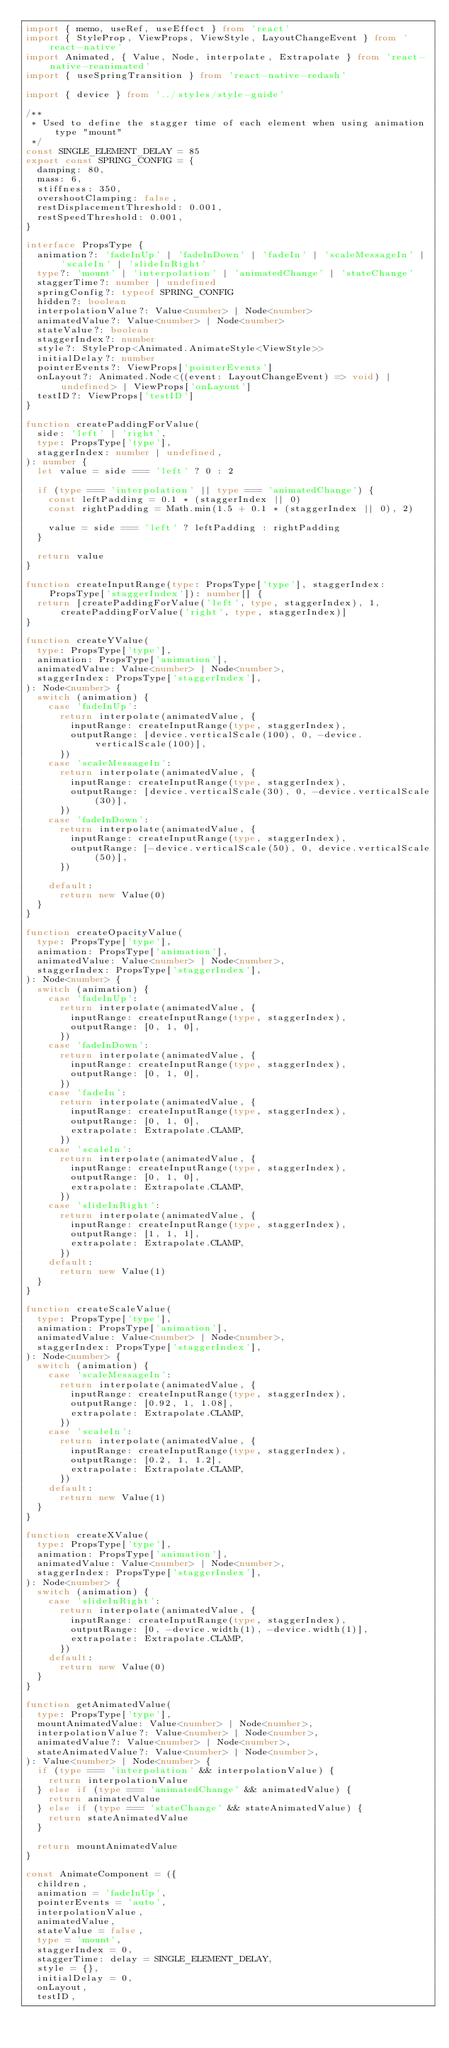Convert code to text. <code><loc_0><loc_0><loc_500><loc_500><_TypeScript_>import { memo, useRef, useEffect } from 'react'
import { StyleProp, ViewProps, ViewStyle, LayoutChangeEvent } from 'react-native'
import Animated, { Value, Node, interpolate, Extrapolate } from 'react-native-reanimated'
import { useSpringTransition } from 'react-native-redash'

import { device } from '../styles/style-guide'

/**
 * Used to define the stagger time of each element when using animation type "mount"
 */
const SINGLE_ELEMENT_DELAY = 85
export const SPRING_CONFIG = {
  damping: 80,
  mass: 6,
  stiffness: 350,
  overshootClamping: false,
  restDisplacementThreshold: 0.001,
  restSpeedThreshold: 0.001,
}

interface PropsType {
  animation?: 'fadeInUp' | 'fadeInDown' | 'fadeIn' | 'scaleMessageIn' | 'scaleIn' | 'slideInRight'
  type?: 'mount' | 'interpolation' | 'animatedChange' | 'stateChange'
  staggerTime?: number | undefined
  springConfig?: typeof SPRING_CONFIG
  hidden?: boolean
  interpolationValue?: Value<number> | Node<number>
  animatedValue?: Value<number> | Node<number>
  stateValue?: boolean
  staggerIndex?: number
  style?: StyleProp<Animated.AnimateStyle<ViewStyle>>
  initialDelay?: number
  pointerEvents?: ViewProps['pointerEvents']
  onLayout?: Animated.Node<((event: LayoutChangeEvent) => void) | undefined> | ViewProps['onLayout']
  testID?: ViewProps['testID']
}

function createPaddingForValue(
  side: 'left' | 'right',
  type: PropsType['type'],
  staggerIndex: number | undefined,
): number {
  let value = side === 'left' ? 0 : 2

  if (type === 'interpolation' || type === 'animatedChange') {
    const leftPadding = 0.1 * (staggerIndex || 0)
    const rightPadding = Math.min(1.5 + 0.1 * (staggerIndex || 0), 2)

    value = side === 'left' ? leftPadding : rightPadding
  }

  return value
}

function createInputRange(type: PropsType['type'], staggerIndex: PropsType['staggerIndex']): number[] {
  return [createPaddingForValue('left', type, staggerIndex), 1, createPaddingForValue('right', type, staggerIndex)]
}

function createYValue(
  type: PropsType['type'],
  animation: PropsType['animation'],
  animatedValue: Value<number> | Node<number>,
  staggerIndex: PropsType['staggerIndex'],
): Node<number> {
  switch (animation) {
    case 'fadeInUp':
      return interpolate(animatedValue, {
        inputRange: createInputRange(type, staggerIndex),
        outputRange: [device.verticalScale(100), 0, -device.verticalScale(100)],
      })
    case 'scaleMessageIn':
      return interpolate(animatedValue, {
        inputRange: createInputRange(type, staggerIndex),
        outputRange: [device.verticalScale(30), 0, -device.verticalScale(30)],
      })
    case 'fadeInDown':
      return interpolate(animatedValue, {
        inputRange: createInputRange(type, staggerIndex),
        outputRange: [-device.verticalScale(50), 0, device.verticalScale(50)],
      })

    default:
      return new Value(0)
  }
}

function createOpacityValue(
  type: PropsType['type'],
  animation: PropsType['animation'],
  animatedValue: Value<number> | Node<number>,
  staggerIndex: PropsType['staggerIndex'],
): Node<number> {
  switch (animation) {
    case 'fadeInUp':
      return interpolate(animatedValue, {
        inputRange: createInputRange(type, staggerIndex),
        outputRange: [0, 1, 0],
      })
    case 'fadeInDown':
      return interpolate(animatedValue, {
        inputRange: createInputRange(type, staggerIndex),
        outputRange: [0, 1, 0],
      })
    case 'fadeIn':
      return interpolate(animatedValue, {
        inputRange: createInputRange(type, staggerIndex),
        outputRange: [0, 1, 0],
        extrapolate: Extrapolate.CLAMP,
      })
    case 'scaleIn':
      return interpolate(animatedValue, {
        inputRange: createInputRange(type, staggerIndex),
        outputRange: [0, 1, 0],
        extrapolate: Extrapolate.CLAMP,
      })
    case 'slideInRight':
      return interpolate(animatedValue, {
        inputRange: createInputRange(type, staggerIndex),
        outputRange: [1, 1, 1],
        extrapolate: Extrapolate.CLAMP,
      })
    default:
      return new Value(1)
  }
}

function createScaleValue(
  type: PropsType['type'],
  animation: PropsType['animation'],
  animatedValue: Value<number> | Node<number>,
  staggerIndex: PropsType['staggerIndex'],
): Node<number> {
  switch (animation) {
    case 'scaleMessageIn':
      return interpolate(animatedValue, {
        inputRange: createInputRange(type, staggerIndex),
        outputRange: [0.92, 1, 1.08],
        extrapolate: Extrapolate.CLAMP,
      })
    case 'scaleIn':
      return interpolate(animatedValue, {
        inputRange: createInputRange(type, staggerIndex),
        outputRange: [0.2, 1, 1.2],
        extrapolate: Extrapolate.CLAMP,
      })
    default:
      return new Value(1)
  }
}

function createXValue(
  type: PropsType['type'],
  animation: PropsType['animation'],
  animatedValue: Value<number> | Node<number>,
  staggerIndex: PropsType['staggerIndex'],
): Node<number> {
  switch (animation) {
    case 'slideInRight':
      return interpolate(animatedValue, {
        inputRange: createInputRange(type, staggerIndex),
        outputRange: [0, -device.width(1), -device.width(1)],
        extrapolate: Extrapolate.CLAMP,
      })
    default:
      return new Value(0)
  }
}

function getAnimatedValue(
  type: PropsType['type'],
  mountAnimatedValue: Value<number> | Node<number>,
  interpolationValue?: Value<number> | Node<number>,
  animatedValue?: Value<number> | Node<number>,
  stateAnimatedValue?: Value<number> | Node<number>,
): Value<number> | Node<number> {
  if (type === 'interpolation' && interpolationValue) {
    return interpolationValue
  } else if (type === 'animatedChange' && animatedValue) {
    return animatedValue
  } else if (type === 'stateChange' && stateAnimatedValue) {
    return stateAnimatedValue
  }

  return mountAnimatedValue
}

const AnimateComponent = ({
  children,
  animation = 'fadeInUp',
  pointerEvents = 'auto',
  interpolationValue,
  animatedValue,
  stateValue = false,
  type = 'mount',
  staggerIndex = 0,
  staggerTime: delay = SINGLE_ELEMENT_DELAY,
  style = {},
  initialDelay = 0,
  onLayout,
  testID,</code> 